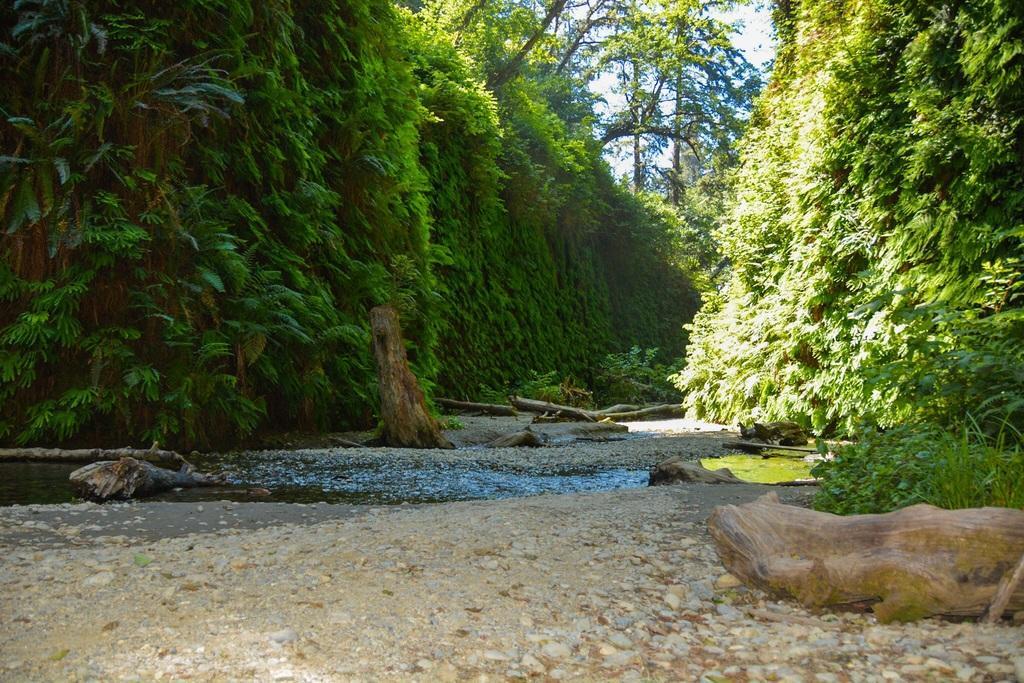Please provide a concise description of this image. In the foreground of this picture, there is a ground and trunks on the ground and we can also see water, trees and the sky. 